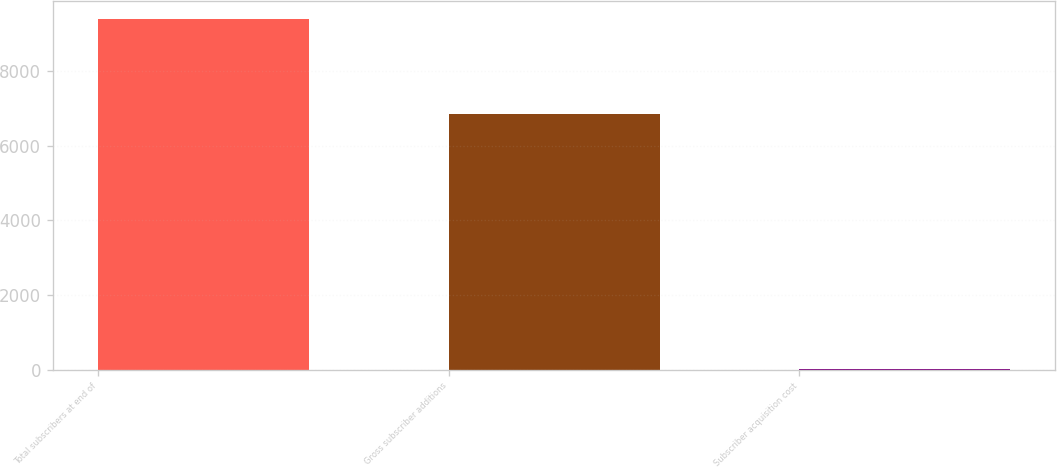Convert chart. <chart><loc_0><loc_0><loc_500><loc_500><bar_chart><fcel>Total subscribers at end of<fcel>Gross subscriber additions<fcel>Subscriber acquisition cost<nl><fcel>9390<fcel>6859<fcel>29.12<nl></chart> 